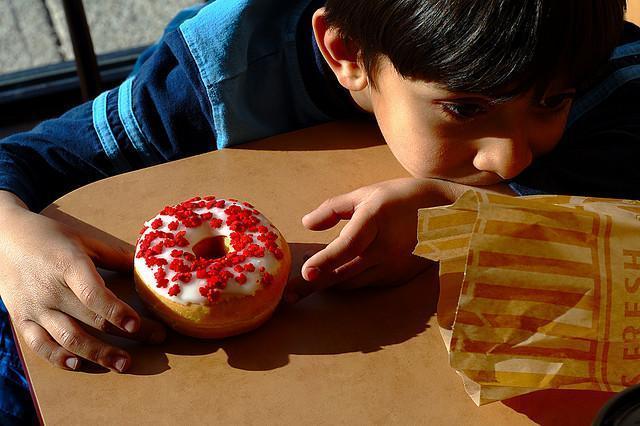Is the caption "The person is on top of the dining table." a true representation of the image?
Answer yes or no. Yes. 